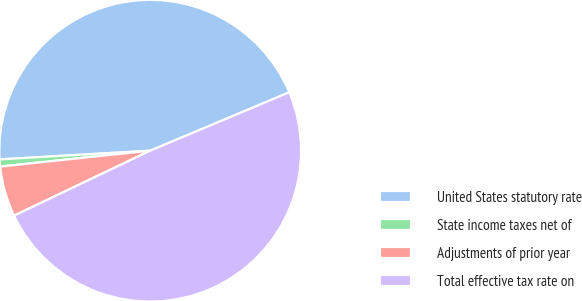Convert chart to OTSL. <chart><loc_0><loc_0><loc_500><loc_500><pie_chart><fcel>United States statutory rate<fcel>State income taxes net of<fcel>Adjustments of prior year<fcel>Total effective tax rate on<nl><fcel>44.59%<fcel>0.76%<fcel>5.41%<fcel>49.24%<nl></chart> 